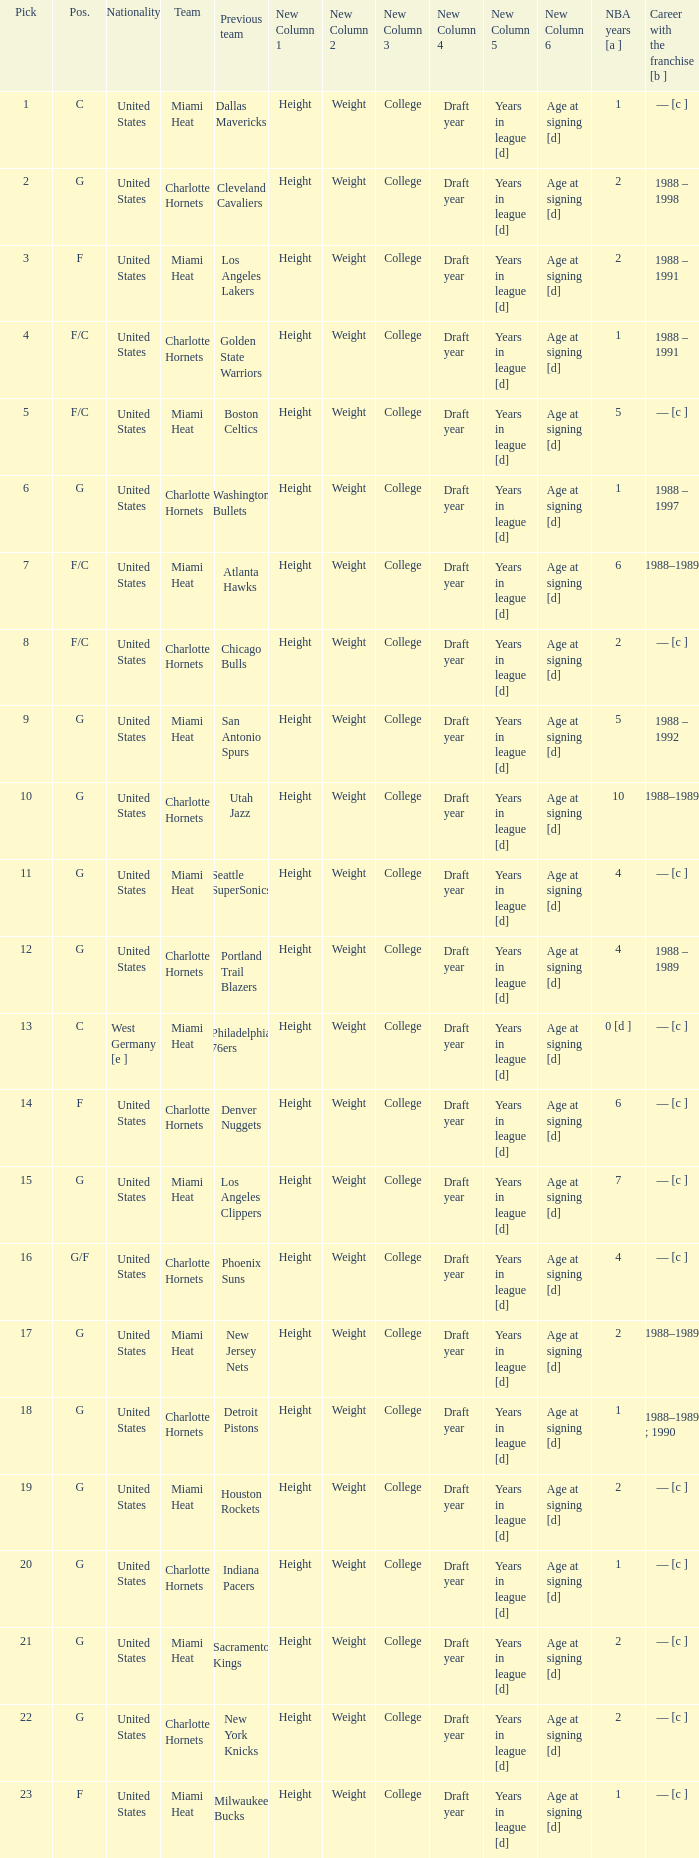What is the previous team of the player with 4 NBA years and a pick less than 16? Seattle SuperSonics, Portland Trail Blazers. 